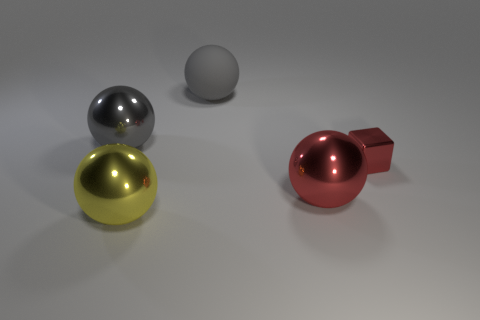Subtract all big yellow balls. How many balls are left? 3 Subtract all gray spheres. How many spheres are left? 2 Add 4 tiny yellow matte blocks. How many objects exist? 9 Subtract all balls. How many objects are left? 1 Subtract all green blocks. How many red spheres are left? 1 Subtract all small shiny things. Subtract all metal balls. How many objects are left? 1 Add 5 tiny red shiny cubes. How many tiny red shiny cubes are left? 6 Add 5 big red things. How many big red things exist? 6 Subtract 1 red balls. How many objects are left? 4 Subtract all gray blocks. Subtract all brown cylinders. How many blocks are left? 1 